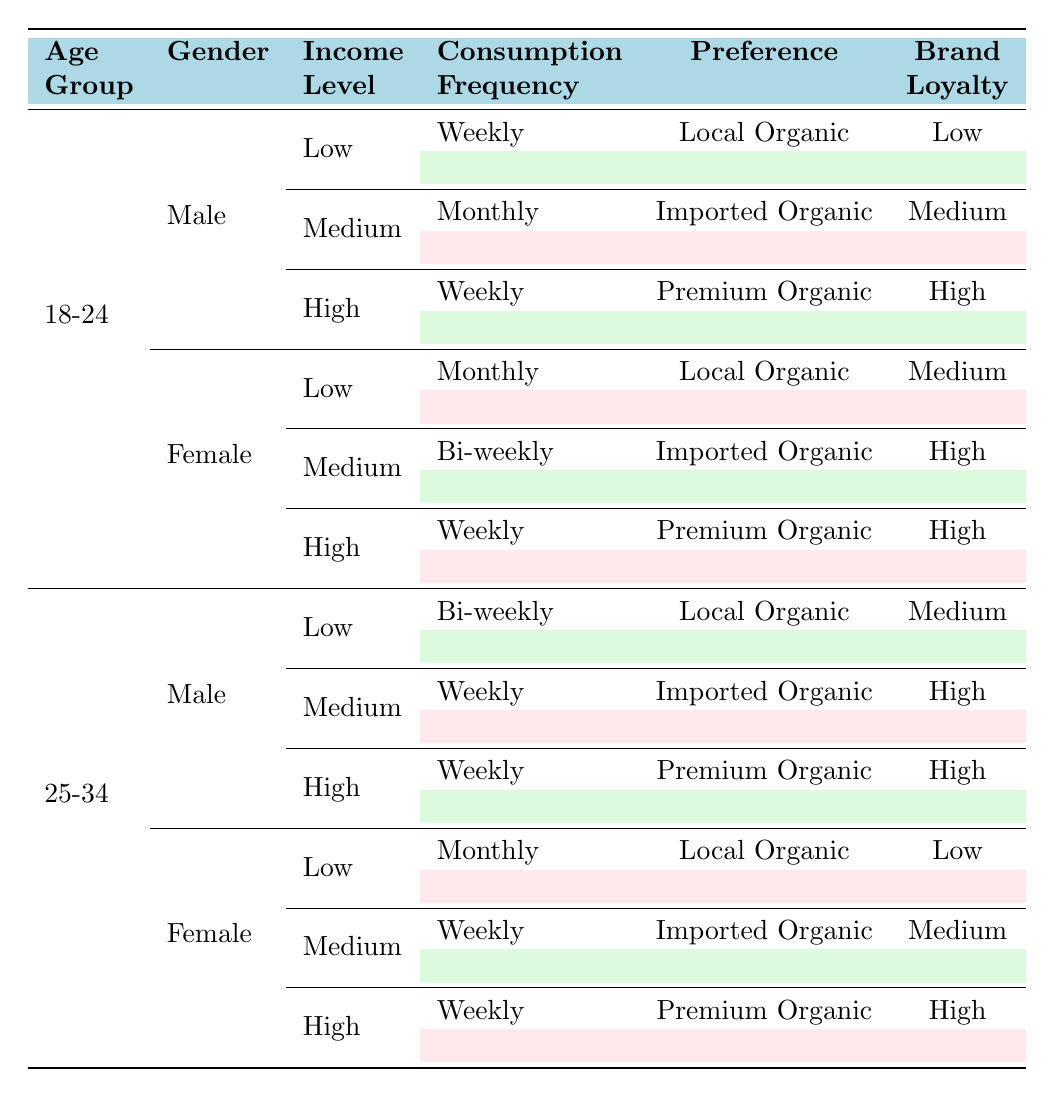What is the consumption frequency for 18-24-year-old males with a high income level? The table shows that 18-24-year-old males with a high income level have a consumption frequency of "Weekly."
Answer: Weekly What preference do 25-34-year-old females with a medium income level have? According to the table, 25-34-year-old females with a medium income level prefer "Imported Organic."
Answer: Imported Organic Is the brand loyalty of low-income female consumers aged 18-24 high or low? The table indicates that low-income female consumers aged 18-24 have a brand loyalty of "Medium," not high.
Answer: No How many demographic groups have a weekly consumption frequency? There are several groups with weekly consumption: 18-24 males (high income) and (high income) females, as well as 25-34 males (medium and high income) and females (medium and high income). If we sum these, we find 6 groups.
Answer: 6 Do both age groups (18-24 and 25-34) have a low preference for local organic honey? The table shows that only 18-24-year-olds with low income (both genders) prefer "Local Organic." The 25-34-year-olds do not have low preference.
Answer: No What is the brand loyalty of high-income males in the 25-34 age group? The table indicates that high-income males in the 25-34 age group have a brand loyalty of "High."
Answer: High What is the average consumption frequency across all low-income consumers in both age groups? The consumption frequencies for low-income consumers are: 18-24 (Monthly) and 25-34 (Bi-weekly). If we count Monthly as 1 and Bi-weekly as 1.5, we calculate the average: (1 + 1.5)/2 = 1.25, which translates to about every 2 weeks.
Answer: Every 2 weeks Are there any females aged 25-34 with low brand loyalty? The table reveals that 25-34 females with low income have low brand loyalty.
Answer: Yes 